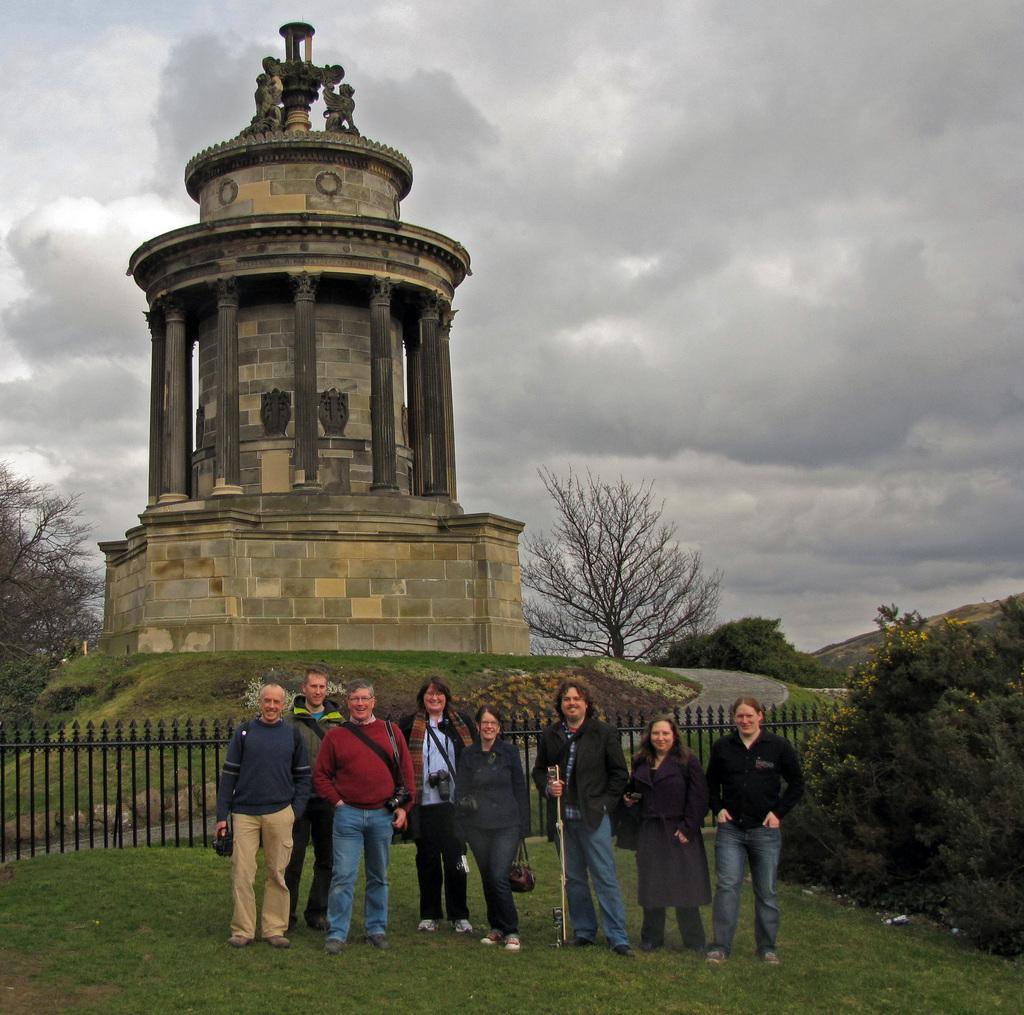How would you summarize this image in a sentence or two? In this picture there is burns monument on the left side of the image and there are people those who are standing at the bottom side of the image, on the grassland and there is a boundary behind them, there is greenery in the image. 